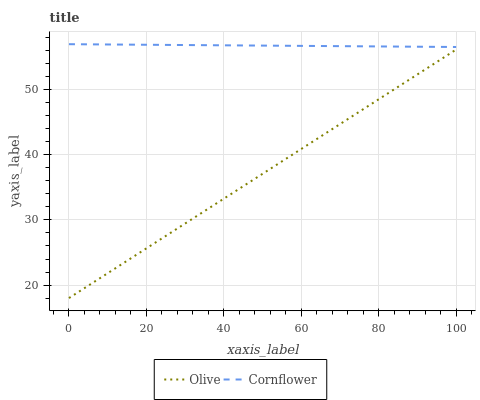Does Olive have the minimum area under the curve?
Answer yes or no. Yes. Does Cornflower have the maximum area under the curve?
Answer yes or no. Yes. Does Cornflower have the minimum area under the curve?
Answer yes or no. No. Is Cornflower the smoothest?
Answer yes or no. Yes. Is Olive the roughest?
Answer yes or no. Yes. Is Cornflower the roughest?
Answer yes or no. No. Does Olive have the lowest value?
Answer yes or no. Yes. Does Cornflower have the lowest value?
Answer yes or no. No. Does Cornflower have the highest value?
Answer yes or no. Yes. Is Olive less than Cornflower?
Answer yes or no. Yes. Is Cornflower greater than Olive?
Answer yes or no. Yes. Does Olive intersect Cornflower?
Answer yes or no. No. 